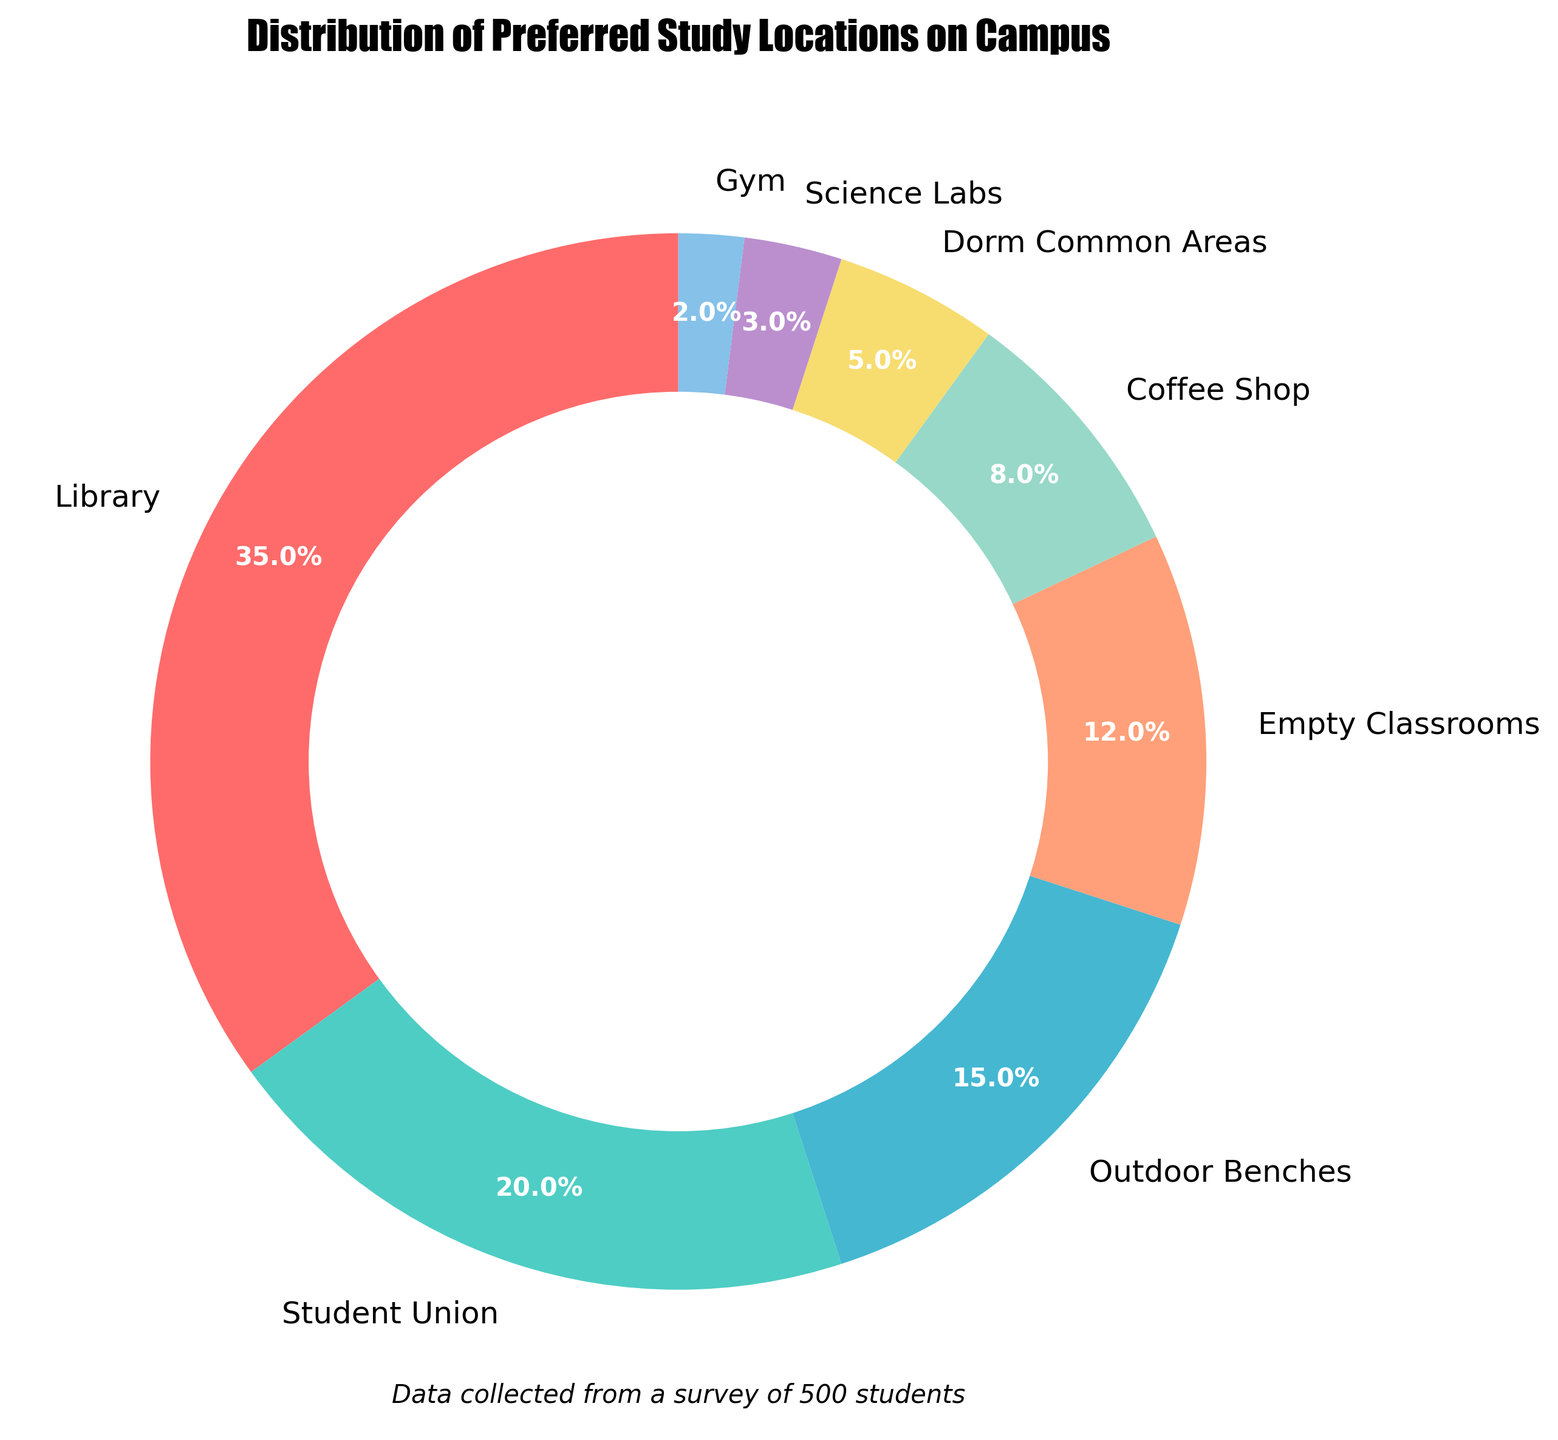What's the most preferred study location on campus? The largest segment of the pie chart represents the study location with the highest percentage. In this figure, it's the Library which has the biggest segment labeled with 35%.
Answer: Library Which study location has the second highest preference? The second largest segment in the pie chart represents the second highest preferred study location, which can be found visually by observing the sizes. The Student Union is the second largest segment with 20%.
Answer: Student Union What is the combined percentage of students who prefer studying in the Library and Student Union? To find the combined percentage, add the individual percentages of the Library and Student Union. The Library has 35% and the Student Union has 20%. Summing these gives 35% + 20% = 55%.
Answer: 55% How does the preference for the Library compare to the Coffee Shop? Comparing the size of the segments, the Library segment (35%) is much larger than the Coffee Shop segment (8%). This means the Library is a more preferred study location than the Coffee Shop.
Answer: The Library is much more preferred Which study location is least preferred by students, and what is its percentage? The smallest segment of the pie chart represents the least preferred study location. This is the Gym with a percentage of 2%.
Answer: Gym, 2% What is the total percentage of students preferring to study in either the Gym or Science Labs? To find the combined percentage, add the individual percentages of the Gym and Science Labs. The Gym has 2% and Science Labs have 3%. Summing these gives 2% + 3% = 5%.
Answer: 5% How many study locations have a preference below 10%? Look at the pie segments with percentages below 10%, which are the Dorm Common Areas (5%), Science Labs (3%), and Gym (2%). Counting these segments gives 3 locations.
Answer: 3 Which study location has a nearly equal preference to Empty Classrooms? Find the segment that is closest in size to Empty Classrooms, which has 12%. The Outdoor Benches segment is 15%, which is close in size.
Answer: Outdoor Benches What is the difference in preference percentage between Outdoor Benches and Coffee Shop? Subtract the smaller percentage from the larger one. The Outdoor Benches have 15% and the Coffee Shop has 8%. The difference is 15% - 8% = 7%.
Answer: 7% Are there more students preferring to study in Dorm Common Areas or Science Labs? Compare the segments for Dorm Common Areas (5%) and Science Labs (3%). The Dorm Common Areas segment is larger, indicating more students prefer it.
Answer: Dorm Common Areas 